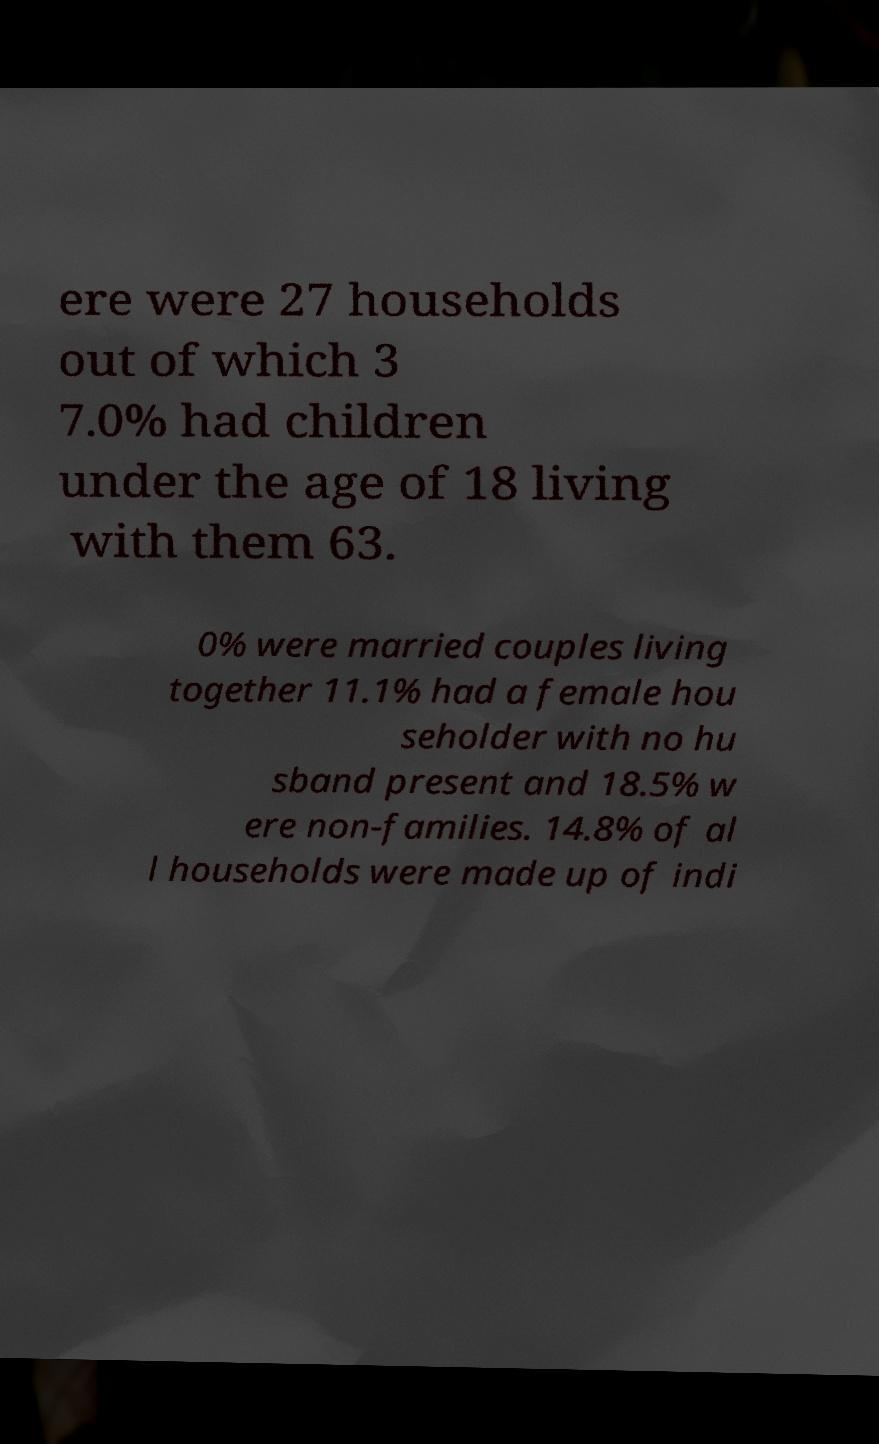Can you accurately transcribe the text from the provided image for me? ere were 27 households out of which 3 7.0% had children under the age of 18 living with them 63. 0% were married couples living together 11.1% had a female hou seholder with no hu sband present and 18.5% w ere non-families. 14.8% of al l households were made up of indi 